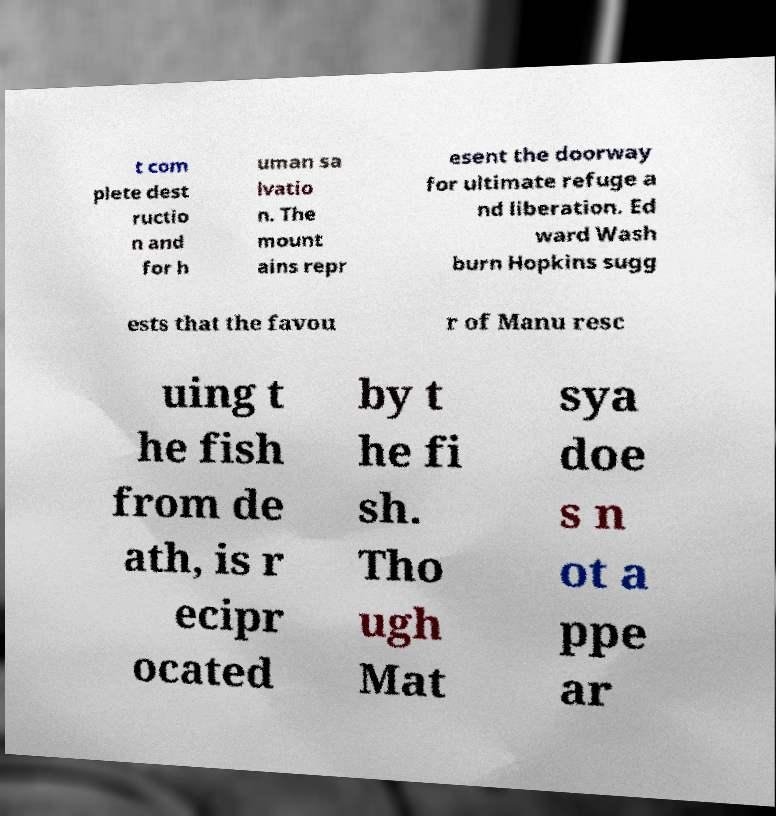Can you read and provide the text displayed in the image?This photo seems to have some interesting text. Can you extract and type it out for me? t com plete dest ructio n and for h uman sa lvatio n. The mount ains repr esent the doorway for ultimate refuge a nd liberation. Ed ward Wash burn Hopkins sugg ests that the favou r of Manu resc uing t he fish from de ath, is r ecipr ocated by t he fi sh. Tho ugh Mat sya doe s n ot a ppe ar 